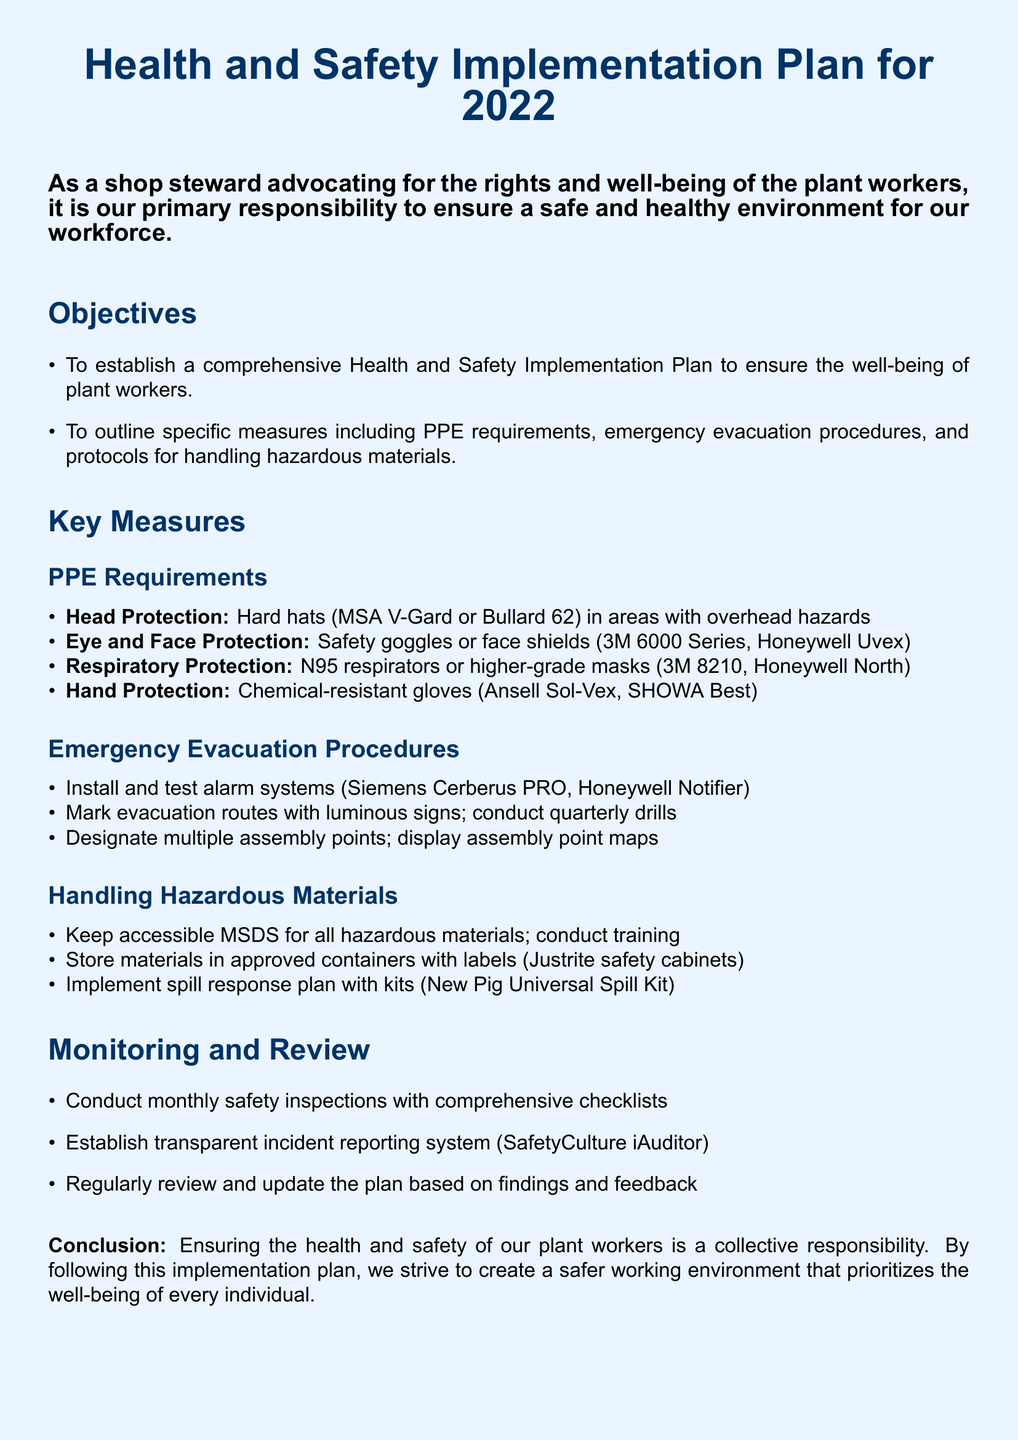What is the purpose of the Health and Safety Implementation Plan? The purpose is to establish a comprehensive plan to ensure the well-being of plant workers.
Answer: To ensure the well-being of plant workers What type of PPE is required for head protection? The document specifies that hard hats from MSA V-Gard or Bullard 62 are required.
Answer: Hard hats (MSA V-Gard or Bullard 62) How often should emergency evacuation drills be conducted? The document states that quarterly drills should be conducted.
Answer: Quarterly What do MSDS stand for? MSDS stands for Material Safety Data Sheets, which are kept accessible for hazardous materials.
Answer: Material Safety Data Sheets What is one of the designated assembly points for evacuation? The document mentions displaying assembly point maps to facilitate this.
Answer: Assembly point maps How many measures are outlined under PPE requirements? There are four measures listed for PPE requirements in the document.
Answer: Four What is the frequency of the safety inspections according to the monitoring section? The plan states that safety inspections are conducted monthly.
Answer: Monthly What type of spill kit is mentioned in the handling hazardous materials section? The New Pig Universal Spill Kit is mentioned for spill response.
Answer: New Pig Universal Spill Kit What system is used for incident reporting? The document outlines the use of SafetyCulture iAuditor for incident reporting.
Answer: SafetyCulture iAuditor 